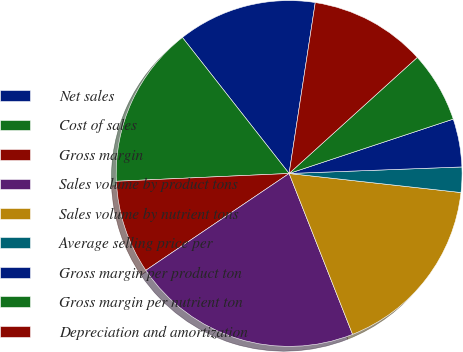Convert chart. <chart><loc_0><loc_0><loc_500><loc_500><pie_chart><fcel>Net sales<fcel>Cost of sales<fcel>Gross margin<fcel>Sales volume by product tons<fcel>Sales volume by nutrient tons<fcel>Average selling price per<fcel>Gross margin per product ton<fcel>Gross margin per nutrient ton<fcel>Depreciation and amortization<nl><fcel>13.0%<fcel>15.13%<fcel>8.74%<fcel>21.52%<fcel>17.26%<fcel>2.36%<fcel>4.49%<fcel>6.62%<fcel>10.87%<nl></chart> 